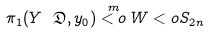<formula> <loc_0><loc_0><loc_500><loc_500>\pi _ { 1 } ( Y \ \mathfrak { D } , y _ { 0 } ) \overset { m } { < o } W < o S _ { 2 n }</formula> 